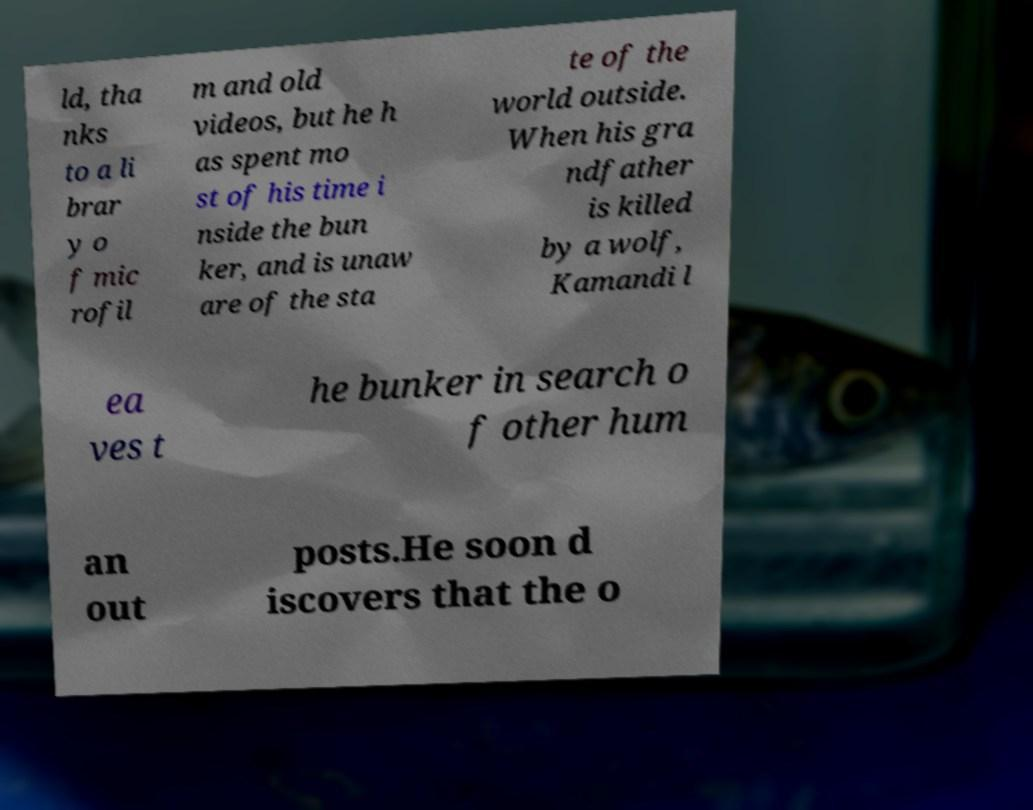Could you extract and type out the text from this image? ld, tha nks to a li brar y o f mic rofil m and old videos, but he h as spent mo st of his time i nside the bun ker, and is unaw are of the sta te of the world outside. When his gra ndfather is killed by a wolf, Kamandi l ea ves t he bunker in search o f other hum an out posts.He soon d iscovers that the o 